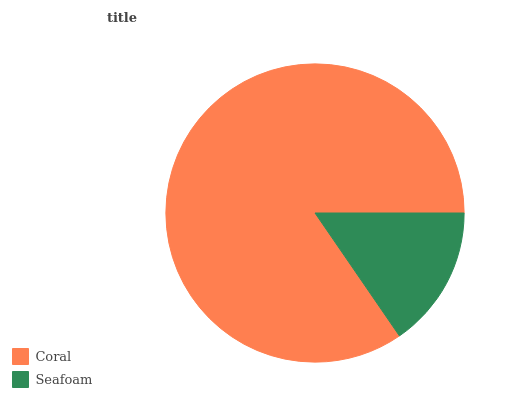Is Seafoam the minimum?
Answer yes or no. Yes. Is Coral the maximum?
Answer yes or no. Yes. Is Seafoam the maximum?
Answer yes or no. No. Is Coral greater than Seafoam?
Answer yes or no. Yes. Is Seafoam less than Coral?
Answer yes or no. Yes. Is Seafoam greater than Coral?
Answer yes or no. No. Is Coral less than Seafoam?
Answer yes or no. No. Is Coral the high median?
Answer yes or no. Yes. Is Seafoam the low median?
Answer yes or no. Yes. Is Seafoam the high median?
Answer yes or no. No. Is Coral the low median?
Answer yes or no. No. 